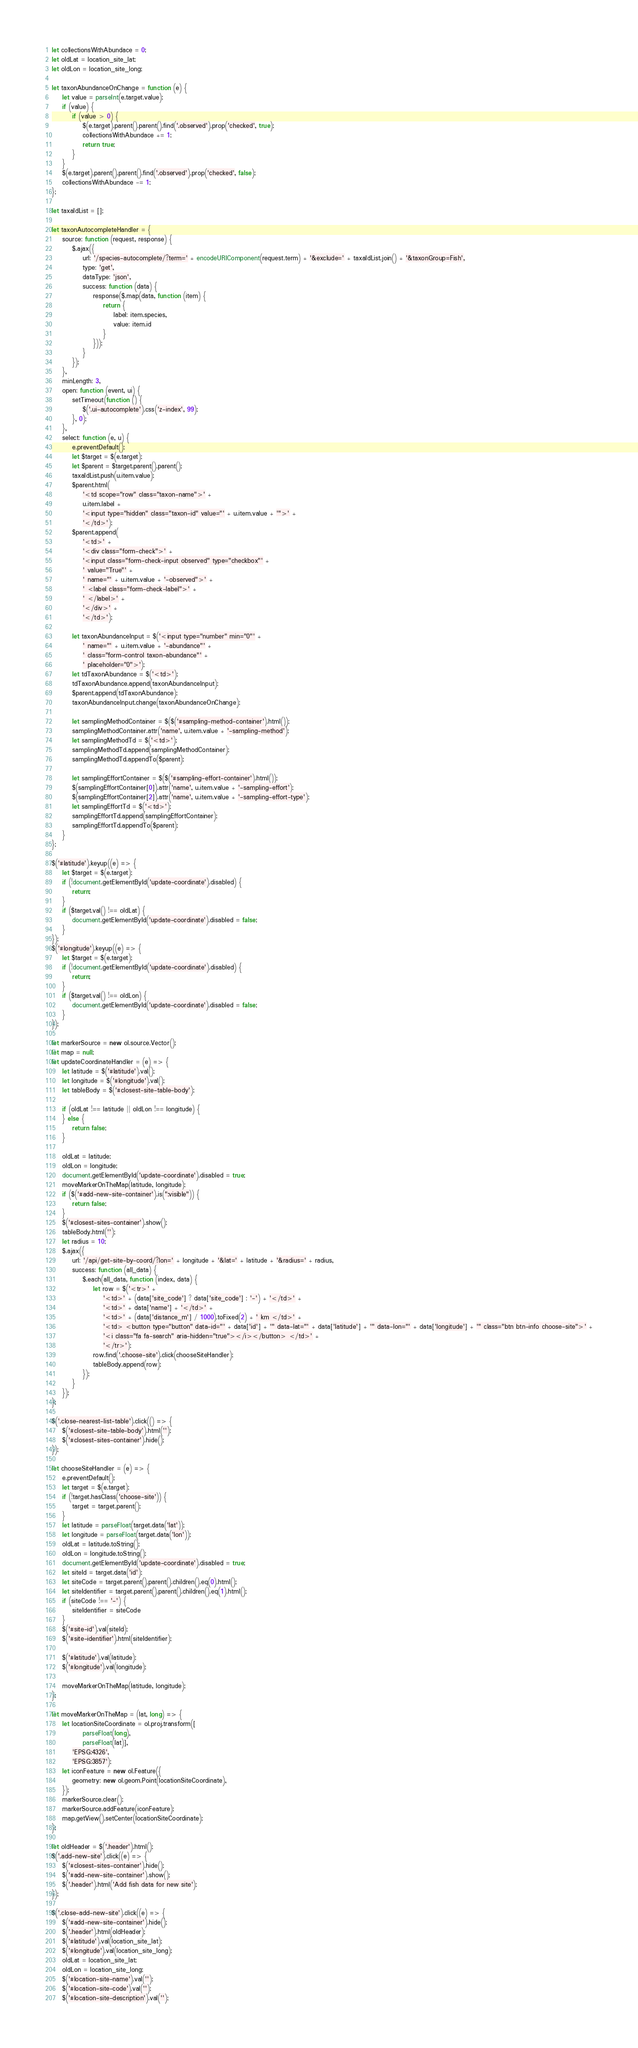Convert code to text. <code><loc_0><loc_0><loc_500><loc_500><_JavaScript_>let collectionsWithAbundace = 0;
let oldLat = location_site_lat;
let oldLon = location_site_long;

let taxonAbundanceOnChange = function (e) {
    let value = parseInt(e.target.value);
    if (value) {
        if (value > 0) {
            $(e.target).parent().parent().find('.observed').prop('checked', true);
            collectionsWithAbundace += 1;
            return true;
        }
    }
    $(e.target).parent().parent().find('.observed').prop('checked', false);
    collectionsWithAbundace -= 1;
};

let taxaIdList = [];

let taxonAutocompleteHandler = {
    source: function (request, response) {
        $.ajax({
            url: '/species-autocomplete/?term=' + encodeURIComponent(request.term) + '&exclude=' + taxaIdList.join() + '&taxonGroup=Fish',
            type: 'get',
            dataType: 'json',
            success: function (data) {
                response($.map(data, function (item) {
                    return {
                        label: item.species,
                        value: item.id
                    }
                }));
            }
        });
    },
    minLength: 3,
    open: function (event, ui) {
        setTimeout(function () {
            $('.ui-autocomplete').css('z-index', 99);
        }, 0);
    },
    select: function (e, u) {
        e.preventDefault();
        let $target = $(e.target);
        let $parent = $target.parent().parent();
        taxaIdList.push(u.item.value);
        $parent.html(
            '<td scope="row" class="taxon-name">' +
            u.item.label +
            '<input type="hidden" class="taxon-id" value="' + u.item.value + '">' +
            '</td>');
        $parent.append(
            '<td>' +
            '<div class="form-check">' +
            '<input class="form-check-input observed" type="checkbox"' +
            ' value="True"' +
            ' name="' + u.item.value + '-observed">' +
            ' <label class="form-check-label">' +
            ' </label>' +
            '</div>' +
            '</td>');

        let taxonAbundanceInput = $('<input type="number" min="0"' +
            ' name="' + u.item.value + '-abundance"' +
            ' class="form-control taxon-abundance"' +
            ' placeholder="0">');
        let tdTaxonAbundance = $('<td>');
        tdTaxonAbundance.append(taxonAbundanceInput);
        $parent.append(tdTaxonAbundance);
        taxonAbundanceInput.change(taxonAbundanceOnChange);

        let samplingMethodContainer = $($('#sampling-method-container').html());
        samplingMethodContainer.attr('name', u.item.value + '-sampling-method');
        let samplingMethodTd = $('<td>');
        samplingMethodTd.append(samplingMethodContainer);
        samplingMethodTd.appendTo($parent);

        let samplingEffortContainer = $($('#sampling-effort-container').html());
        $(samplingEffortContainer[0]).attr('name', u.item.value + '-sampling-effort');
        $(samplingEffortContainer[2]).attr('name', u.item.value + '-sampling-effort-type');
        let samplingEffortTd = $('<td>');
        samplingEffortTd.append(samplingEffortContainer);
        samplingEffortTd.appendTo($parent);
    }
};

$('#latitude').keyup((e) => {
    let $target = $(e.target);
    if (!document.getElementById('update-coordinate').disabled) {
        return;
    }
    if ($target.val() !== oldLat) {
        document.getElementById('update-coordinate').disabled = false;
    }
});
$('#longitude').keyup((e) => {
    let $target = $(e.target);
    if (!document.getElementById('update-coordinate').disabled) {
        return;
    }
    if ($target.val() !== oldLon) {
        document.getElementById('update-coordinate').disabled = false;
    }
});

let markerSource = new ol.source.Vector();
let map = null;
let updateCoordinateHandler = (e) => {
    let latitude = $('#latitude').val();
    let longitude = $('#longitude').val();
    let tableBody = $('#closest-site-table-body');

    if (oldLat !== latitude || oldLon !== longitude) {
    } else {
        return false;
    }

    oldLat = latitude;
    oldLon = longitude;
    document.getElementById('update-coordinate').disabled = true;
    moveMarkerOnTheMap(latitude, longitude);
    if ($('#add-new-site-container').is(":visible")) {
        return false;
    }
    $('#closest-sites-container').show();
    tableBody.html('');
    let radius = 10;
    $.ajax({
        url: '/api/get-site-by-coord/?lon=' + longitude + '&lat=' + latitude + '&radius=' + radius,
        success: function (all_data) {
            $.each(all_data, function (index, data) {
                let row = $('<tr>' +
                    '<td>' + (data['site_code'] ? data['site_code'] : '-') + '</td>' +
                    '<td>' + data['name'] + '</td>' +
                    '<td>' + (data['distance_m'] / 1000).toFixed(2) + ' km </td>' +
                    '<td> <button type="button" data-id="' + data['id'] + '" data-lat="' + data['latitude'] + '" data-lon="' + data['longitude'] + '" class="btn btn-info choose-site">' +
                    '<i class="fa fa-search" aria-hidden="true"></i></button> </td>' +
                    '</tr>');
                row.find('.choose-site').click(chooseSiteHandler);
                tableBody.append(row);
            });
        }
    });
};

$('.close-nearest-list-table').click(() => {
    $('#closest-site-table-body').html('');
    $('#closest-sites-container').hide();
});

let chooseSiteHandler = (e) => {
    e.preventDefault();
    let target = $(e.target);
    if (!target.hasClass('choose-site')) {
        target = target.parent();
    }
    let latitude = parseFloat(target.data('lat'));
    let longitude = parseFloat(target.data('lon'));
    oldLat = latitude.toString();
    oldLon = longitude.toString();
    document.getElementById('update-coordinate').disabled = true;
    let siteId = target.data('id');
    let siteCode = target.parent().parent().children().eq(0).html();
    let siteIdentifier = target.parent().parent().children().eq(1).html();
    if (siteCode !== '-') {
        siteIdentifier = siteCode
    }
    $('#site-id').val(siteId);
    $('#site-identifier').html(siteIdentifier);

    $('#latitude').val(latitude);
    $('#longitude').val(longitude);

    moveMarkerOnTheMap(latitude, longitude);
};

let moveMarkerOnTheMap = (lat, long) => {
    let locationSiteCoordinate = ol.proj.transform([
            parseFloat(long),
            parseFloat(lat)],
        'EPSG:4326',
        'EPSG:3857');
    let iconFeature = new ol.Feature({
        geometry: new ol.geom.Point(locationSiteCoordinate),
    });
    markerSource.clear();
    markerSource.addFeature(iconFeature);
    map.getView().setCenter(locationSiteCoordinate);
};

let oldHeader = $('.header').html();
$('.add-new-site').click((e) => {
    $('#closest-sites-container').hide();
    $('#add-new-site-container').show();
    $('.header').html('Add fish data for new site');
});

$('.close-add-new-site').click((e) => {
    $('#add-new-site-container').hide();
    $('.header').html(oldHeader);
    $('#latitude').val(location_site_lat);
    $('#longitude').val(location_site_long);
    oldLat = location_site_lat;
    oldLon = location_site_long;
    $('#location-site-name').val('');
    $('#location-site-code').val('');
    $('#location-site-description').val('');</code> 